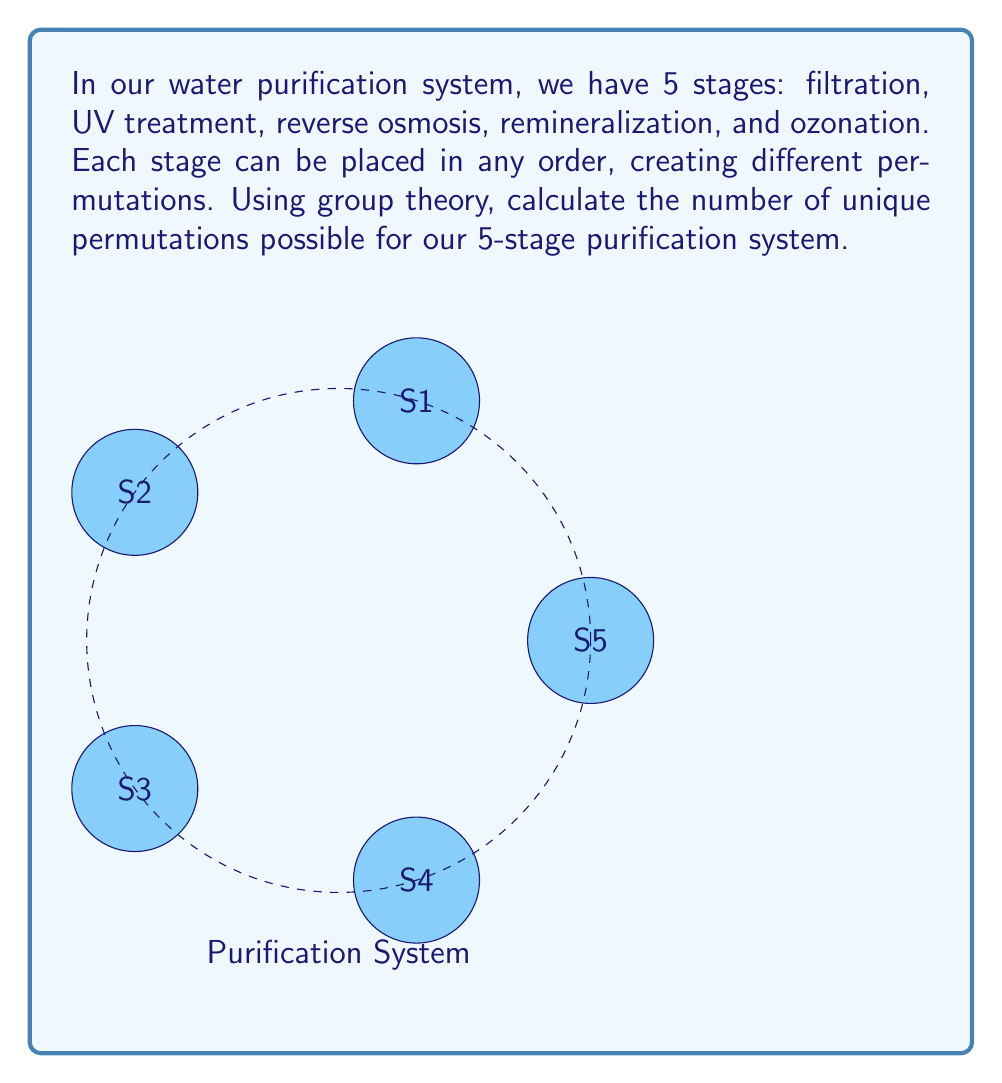What is the answer to this math problem? To solve this problem using group theory, we can consider the permutations of the 5 stages as elements of the symmetric group $S_5$.

1) In group theory, the symmetric group $S_n$ represents all possible permutations of $n$ distinct objects.

2) The order of $S_n$ (i.e., the number of elements in the group) is given by $n!$.

3) In this case, we have 5 stages, so we are working with $S_5$.

4) The number of permutations is equal to the order of $S_5$, which is $5!$.

5) Let's calculate $5!$:

   $$5! = 5 \times 4 \times 3 \times 2 \times 1 = 120$$

Therefore, there are 120 unique permutations possible for the 5-stage purification system.

Note: Each permutation represents a different order of the purification stages, which could potentially affect the efficiency and effectiveness of the purification process. However, as a skeptical CEO, you might want to investigate whether all these permutations actually produce significantly different results in terms of water quality.
Answer: $120$ 